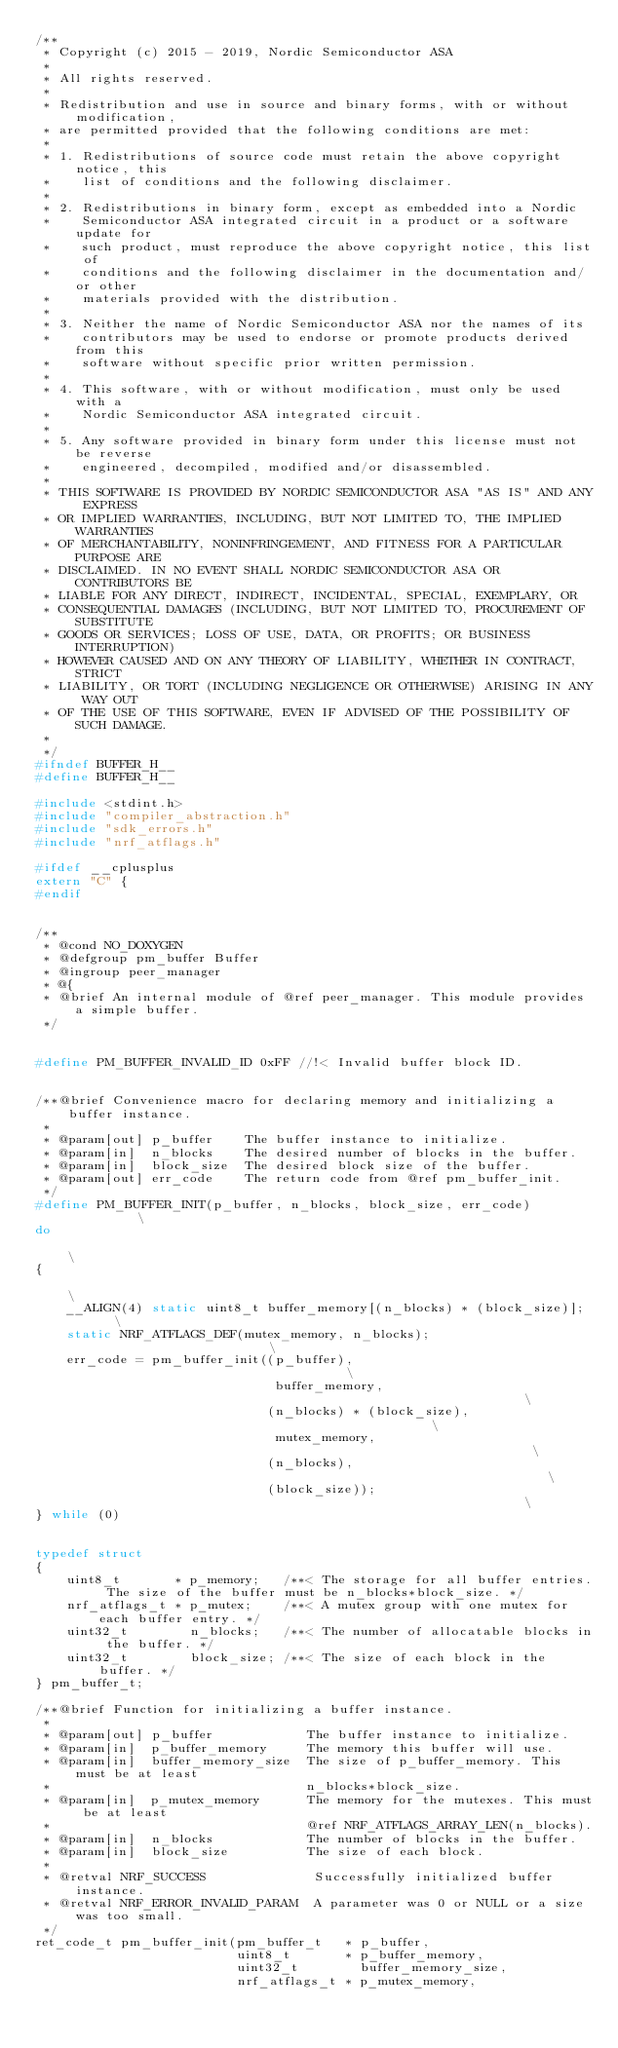<code> <loc_0><loc_0><loc_500><loc_500><_C_>/**
 * Copyright (c) 2015 - 2019, Nordic Semiconductor ASA
 *
 * All rights reserved.
 *
 * Redistribution and use in source and binary forms, with or without modification,
 * are permitted provided that the following conditions are met:
 *
 * 1. Redistributions of source code must retain the above copyright notice, this
 *    list of conditions and the following disclaimer.
 *
 * 2. Redistributions in binary form, except as embedded into a Nordic
 *    Semiconductor ASA integrated circuit in a product or a software update for
 *    such product, must reproduce the above copyright notice, this list of
 *    conditions and the following disclaimer in the documentation and/or other
 *    materials provided with the distribution.
 *
 * 3. Neither the name of Nordic Semiconductor ASA nor the names of its
 *    contributors may be used to endorse or promote products derived from this
 *    software without specific prior written permission.
 *
 * 4. This software, with or without modification, must only be used with a
 *    Nordic Semiconductor ASA integrated circuit.
 *
 * 5. Any software provided in binary form under this license must not be reverse
 *    engineered, decompiled, modified and/or disassembled.
 *
 * THIS SOFTWARE IS PROVIDED BY NORDIC SEMICONDUCTOR ASA "AS IS" AND ANY EXPRESS
 * OR IMPLIED WARRANTIES, INCLUDING, BUT NOT LIMITED TO, THE IMPLIED WARRANTIES
 * OF MERCHANTABILITY, NONINFRINGEMENT, AND FITNESS FOR A PARTICULAR PURPOSE ARE
 * DISCLAIMED. IN NO EVENT SHALL NORDIC SEMICONDUCTOR ASA OR CONTRIBUTORS BE
 * LIABLE FOR ANY DIRECT, INDIRECT, INCIDENTAL, SPECIAL, EXEMPLARY, OR
 * CONSEQUENTIAL DAMAGES (INCLUDING, BUT NOT LIMITED TO, PROCUREMENT OF SUBSTITUTE
 * GOODS OR SERVICES; LOSS OF USE, DATA, OR PROFITS; OR BUSINESS INTERRUPTION)
 * HOWEVER CAUSED AND ON ANY THEORY OF LIABILITY, WHETHER IN CONTRACT, STRICT
 * LIABILITY, OR TORT (INCLUDING NEGLIGENCE OR OTHERWISE) ARISING IN ANY WAY OUT
 * OF THE USE OF THIS SOFTWARE, EVEN IF ADVISED OF THE POSSIBILITY OF SUCH DAMAGE.
 *
 */
#ifndef BUFFER_H__
#define BUFFER_H__

#include <stdint.h>
#include "compiler_abstraction.h"
#include "sdk_errors.h"
#include "nrf_atflags.h"

#ifdef __cplusplus
extern "C" {
#endif


/**
 * @cond NO_DOXYGEN
 * @defgroup pm_buffer Buffer
 * @ingroup peer_manager
 * @{
 * @brief An internal module of @ref peer_manager. This module provides a simple buffer.
 */


#define PM_BUFFER_INVALID_ID 0xFF //!< Invalid buffer block ID.


/**@brief Convenience macro for declaring memory and initializing a buffer instance.
 *
 * @param[out] p_buffer    The buffer instance to initialize.
 * @param[in]  n_blocks    The desired number of blocks in the buffer.
 * @param[in]  block_size  The desired block size of the buffer.
 * @param[out] err_code    The return code from @ref pm_buffer_init.
 */
#define PM_BUFFER_INIT(p_buffer, n_blocks, block_size, err_code)          \
do                                                                        \
{                                                                         \
    __ALIGN(4) static uint8_t buffer_memory[(n_blocks) * (block_size)];   \
    static NRF_ATFLAGS_DEF(mutex_memory, n_blocks);                       \
    err_code = pm_buffer_init((p_buffer),                                 \
                               buffer_memory,                             \
                              (n_blocks) * (block_size),                  \
                               mutex_memory,                              \
                              (n_blocks),                                 \
                              (block_size));                              \
} while (0)


typedef struct
{
    uint8_t       * p_memory;   /**< The storage for all buffer entries. The size of the buffer must be n_blocks*block_size. */
    nrf_atflags_t * p_mutex;    /**< A mutex group with one mutex for each buffer entry. */
    uint32_t        n_blocks;   /**< The number of allocatable blocks in the buffer. */
    uint32_t        block_size; /**< The size of each block in the buffer. */
} pm_buffer_t;

/**@brief Function for initializing a buffer instance.
 *
 * @param[out] p_buffer            The buffer instance to initialize.
 * @param[in]  p_buffer_memory     The memory this buffer will use.
 * @param[in]  buffer_memory_size  The size of p_buffer_memory. This must be at least
 *                                 n_blocks*block_size.
 * @param[in]  p_mutex_memory      The memory for the mutexes. This must be at least
 *                                 @ref NRF_ATFLAGS_ARRAY_LEN(n_blocks).
 * @param[in]  n_blocks            The number of blocks in the buffer.
 * @param[in]  block_size          The size of each block.
 *
 * @retval NRF_SUCCESS              Successfully initialized buffer instance.
 * @retval NRF_ERROR_INVALID_PARAM  A parameter was 0 or NULL or a size was too small.
 */
ret_code_t pm_buffer_init(pm_buffer_t   * p_buffer,
                          uint8_t       * p_buffer_memory,
                          uint32_t        buffer_memory_size,
                          nrf_atflags_t * p_mutex_memory,</code> 